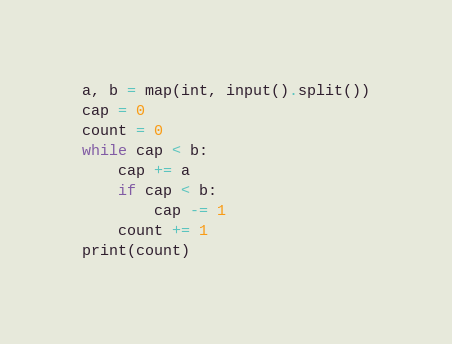<code> <loc_0><loc_0><loc_500><loc_500><_Python_>a, b = map(int, input().split())
cap = 0
count = 0
while cap < b:
    cap += a
    if cap < b:
        cap -= 1
    count += 1
print(count)</code> 